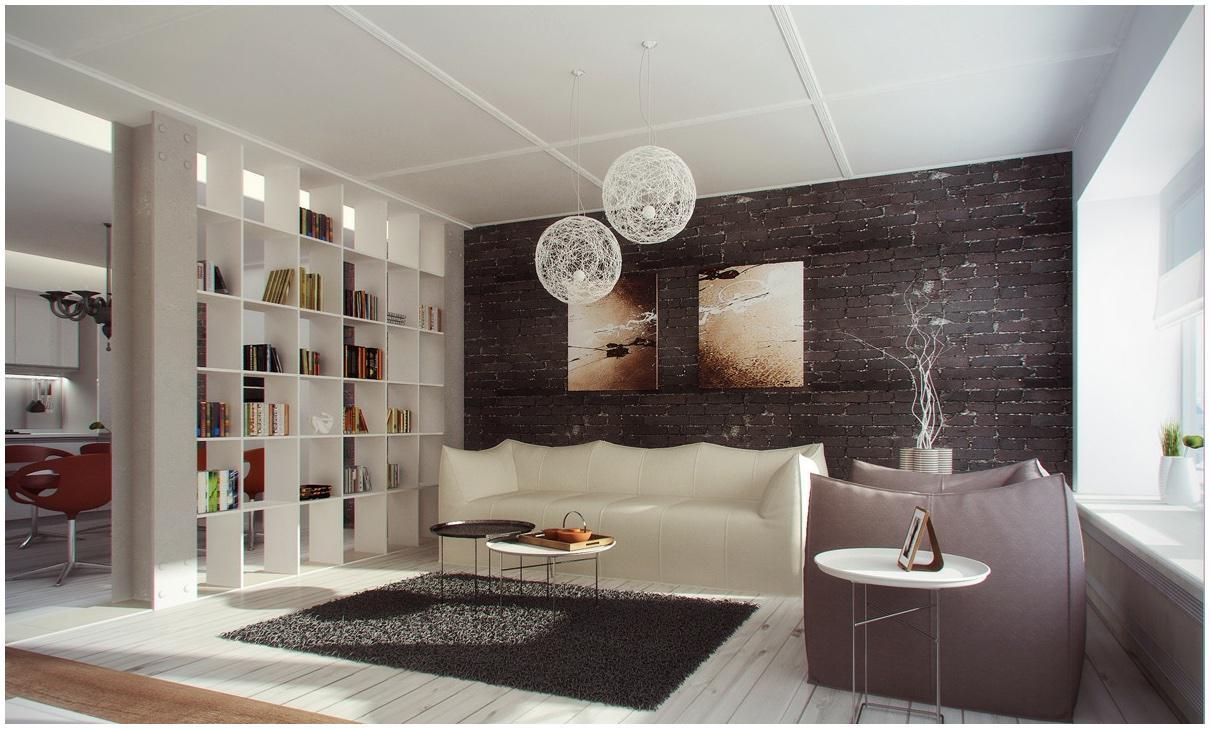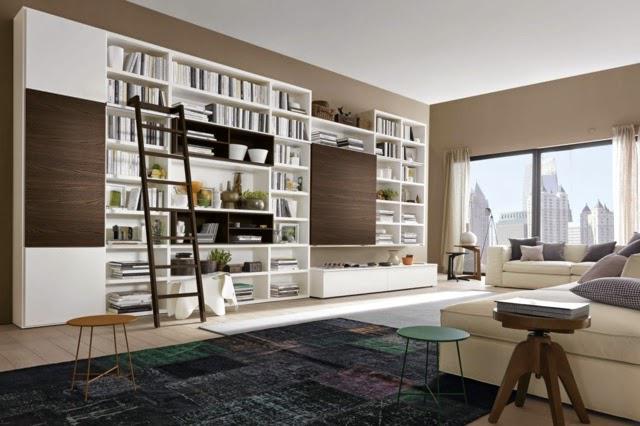The first image is the image on the left, the second image is the image on the right. Given the left and right images, does the statement "The lamp in the image on the left is sitting on a table." hold true? Answer yes or no. No. The first image is the image on the left, the second image is the image on the right. Assess this claim about the two images: "One image shows a room with black bookshelves along one side of a storage unit, with a TV in the center and glass-fronted squares opposite the bookshelves.". Correct or not? Answer yes or no. No. 